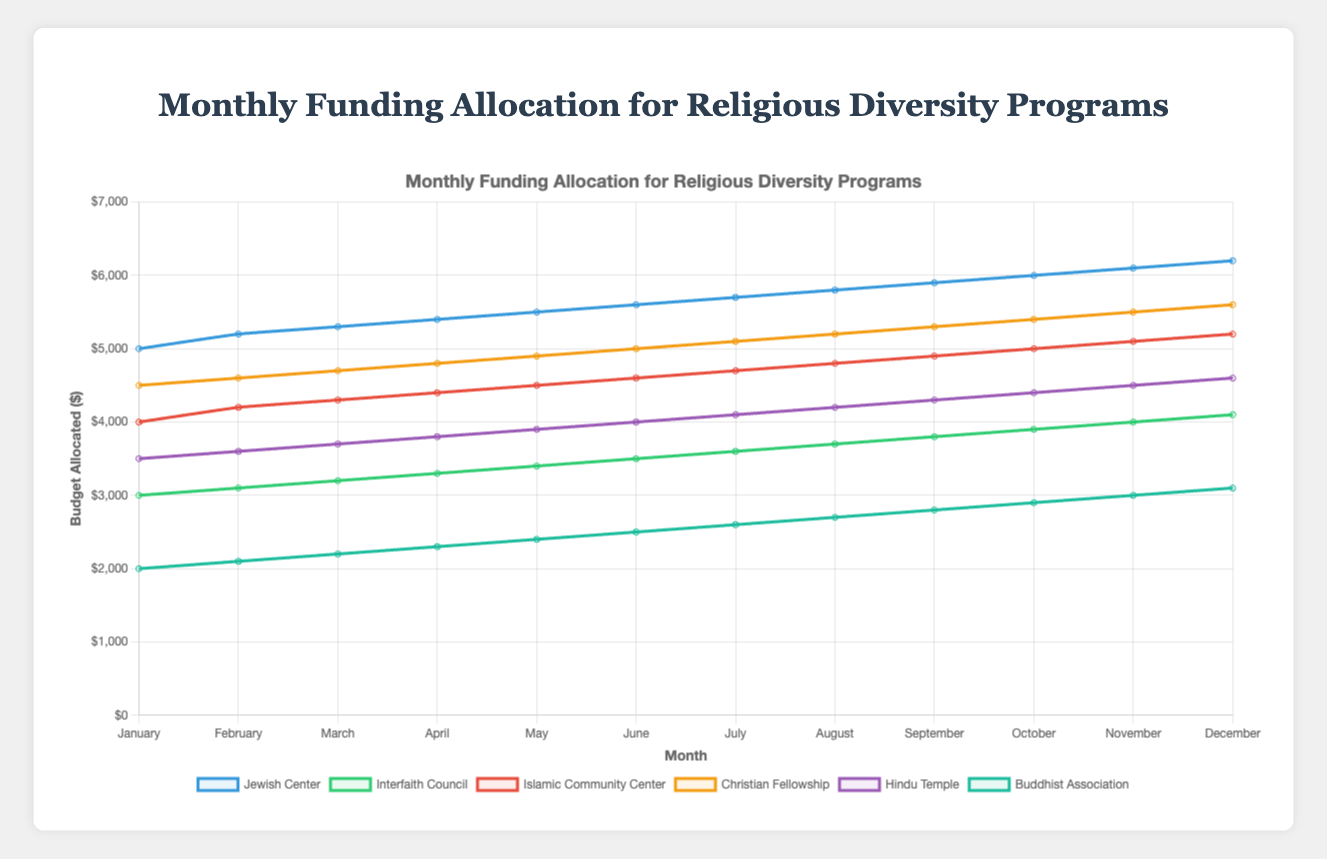Which religious organization saw the highest increase in funding from January to December? We observe the Jewish Center's allocated budget in January at $5000 and in December at $6200, an increase of $1200. Repeating this process for other organizations, we find their respective increases are smaller.
Answer: Jewish Center By how much did the budget of the Buddhist Association change from May to October? The Buddhist Association had $2400 in May and $2900 in October. The difference is $2900 - $2400, which equals $500.
Answer: $500 Which two organizations had the most similar budgets in August? Observing the chart for August, the budgets for the Buddhist Association and the Hindu Temple seem closest at $2700 and $4200, respectively.
Answer: Buddhist Association and Hindu Temple What was the total budget allocated to the Christian Fellowship over the 12 months? Adding the monthly budget allocations for Christian Fellowship: $4500 + $4600 + $4700 + $4800 + $4900 + $5000 + $5100 + $5200 + $5300 + $5400 + $5500 + $5600, resulting in $59600.
Answer: $59600 Did any organization's budget remain constant throughout the twelve months? From the visual inspection, no budget allocation lines are horizontal, indicating that all budgets changed over the period.
Answer: No 